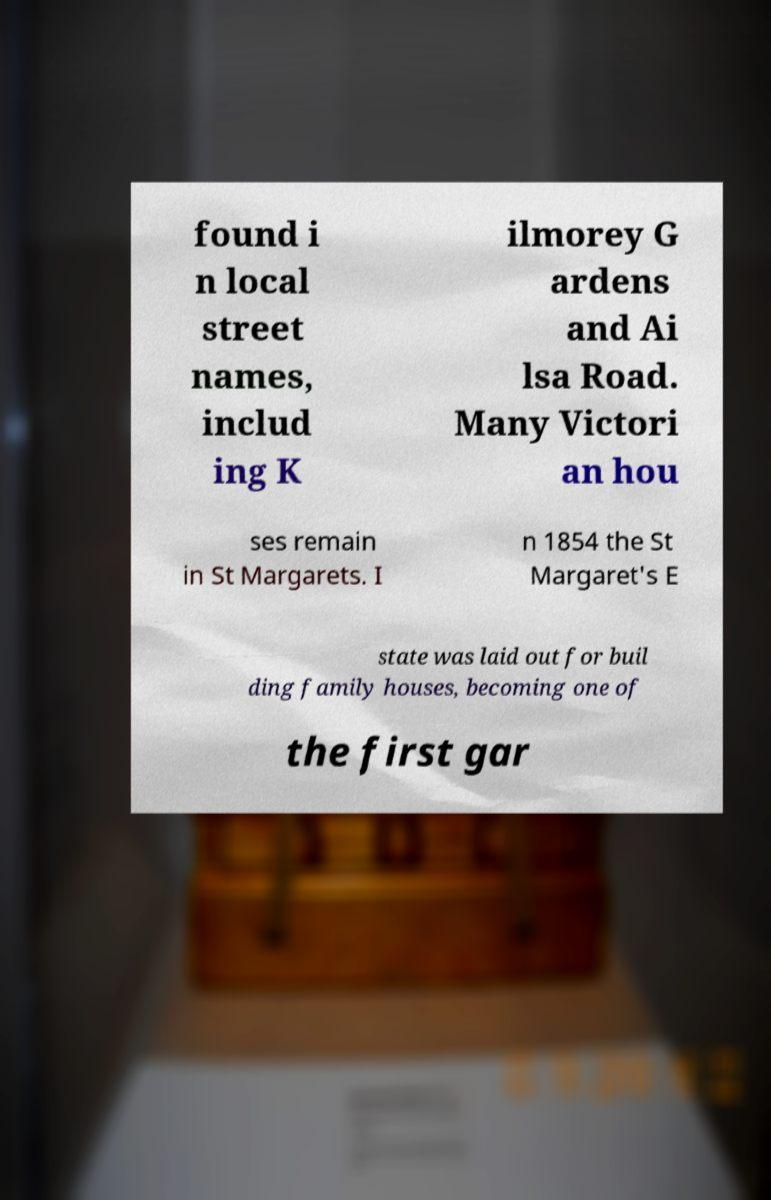I need the written content from this picture converted into text. Can you do that? found i n local street names, includ ing K ilmorey G ardens and Ai lsa Road. Many Victori an hou ses remain in St Margarets. I n 1854 the St Margaret's E state was laid out for buil ding family houses, becoming one of the first gar 